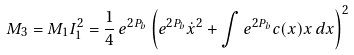<formula> <loc_0><loc_0><loc_500><loc_500>M _ { 3 } = M _ { 1 } I _ { 1 } ^ { 2 } = \frac { 1 } { 4 } \, e ^ { 2 P _ { b } } \left ( e ^ { 2 P _ { b } } \dot { x } ^ { 2 } + \int e ^ { 2 P _ { b } } c ( x ) x \, d x \right ) ^ { 2 }</formula> 